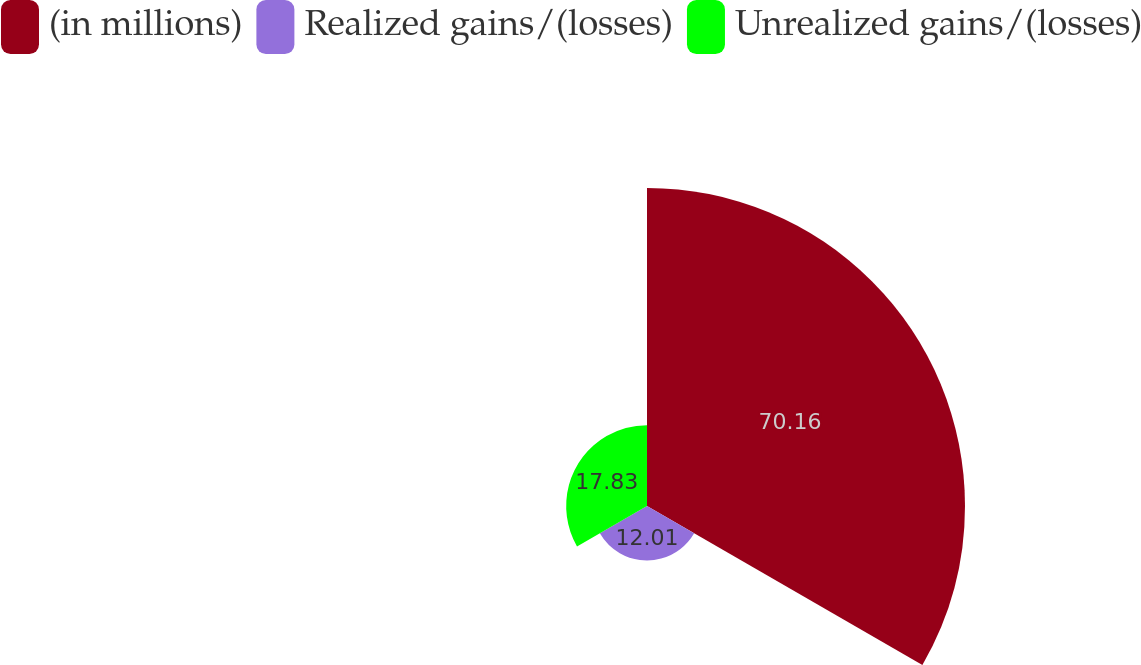Convert chart to OTSL. <chart><loc_0><loc_0><loc_500><loc_500><pie_chart><fcel>(in millions)<fcel>Realized gains/(losses)<fcel>Unrealized gains/(losses)<nl><fcel>70.16%<fcel>12.01%<fcel>17.83%<nl></chart> 